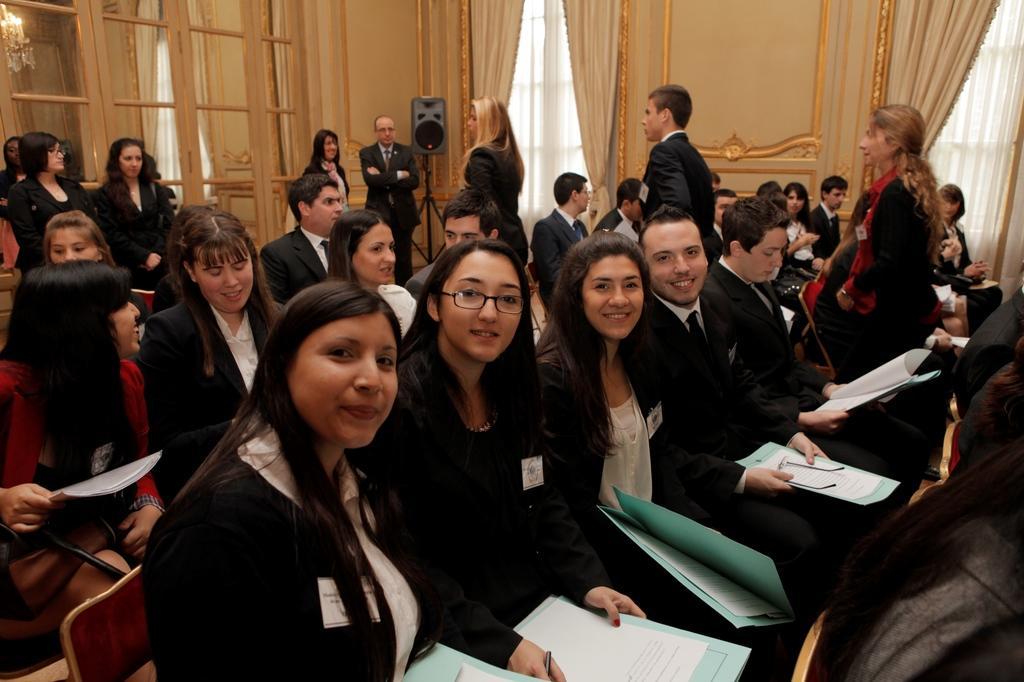Please provide a concise description of this image. In this picture, we see many people are sitting on the chairs and most of them are holding the files and papers in their hands. Behind them, we see the people are standing. Beside them, we see a stand and a speaker box. In the background, we see a wall, windows and the curtains. In the left top, we see the candle stand and the candle. In front of the picture, we see the people are smiling and they are posing for the photo. 